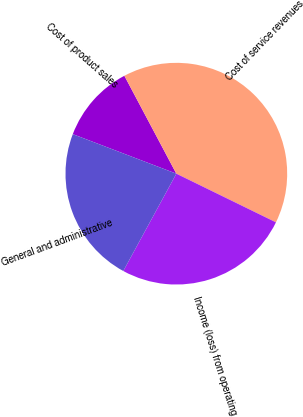Convert chart to OTSL. <chart><loc_0><loc_0><loc_500><loc_500><pie_chart><fcel>Cost of product sales<fcel>Cost of service revenues<fcel>Income (loss) from operating<fcel>General and administrative<nl><fcel>11.43%<fcel>40.0%<fcel>25.71%<fcel>22.86%<nl></chart> 